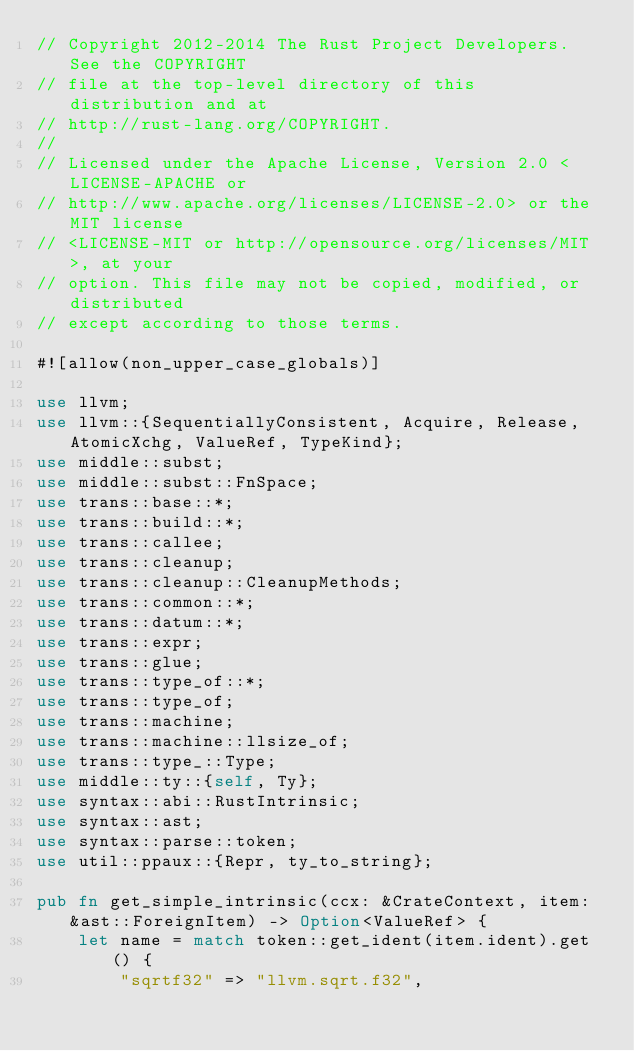<code> <loc_0><loc_0><loc_500><loc_500><_Rust_>// Copyright 2012-2014 The Rust Project Developers. See the COPYRIGHT
// file at the top-level directory of this distribution and at
// http://rust-lang.org/COPYRIGHT.
//
// Licensed under the Apache License, Version 2.0 <LICENSE-APACHE or
// http://www.apache.org/licenses/LICENSE-2.0> or the MIT license
// <LICENSE-MIT or http://opensource.org/licenses/MIT>, at your
// option. This file may not be copied, modified, or distributed
// except according to those terms.

#![allow(non_upper_case_globals)]

use llvm;
use llvm::{SequentiallyConsistent, Acquire, Release, AtomicXchg, ValueRef, TypeKind};
use middle::subst;
use middle::subst::FnSpace;
use trans::base::*;
use trans::build::*;
use trans::callee;
use trans::cleanup;
use trans::cleanup::CleanupMethods;
use trans::common::*;
use trans::datum::*;
use trans::expr;
use trans::glue;
use trans::type_of::*;
use trans::type_of;
use trans::machine;
use trans::machine::llsize_of;
use trans::type_::Type;
use middle::ty::{self, Ty};
use syntax::abi::RustIntrinsic;
use syntax::ast;
use syntax::parse::token;
use util::ppaux::{Repr, ty_to_string};

pub fn get_simple_intrinsic(ccx: &CrateContext, item: &ast::ForeignItem) -> Option<ValueRef> {
    let name = match token::get_ident(item.ident).get() {
        "sqrtf32" => "llvm.sqrt.f32",</code> 